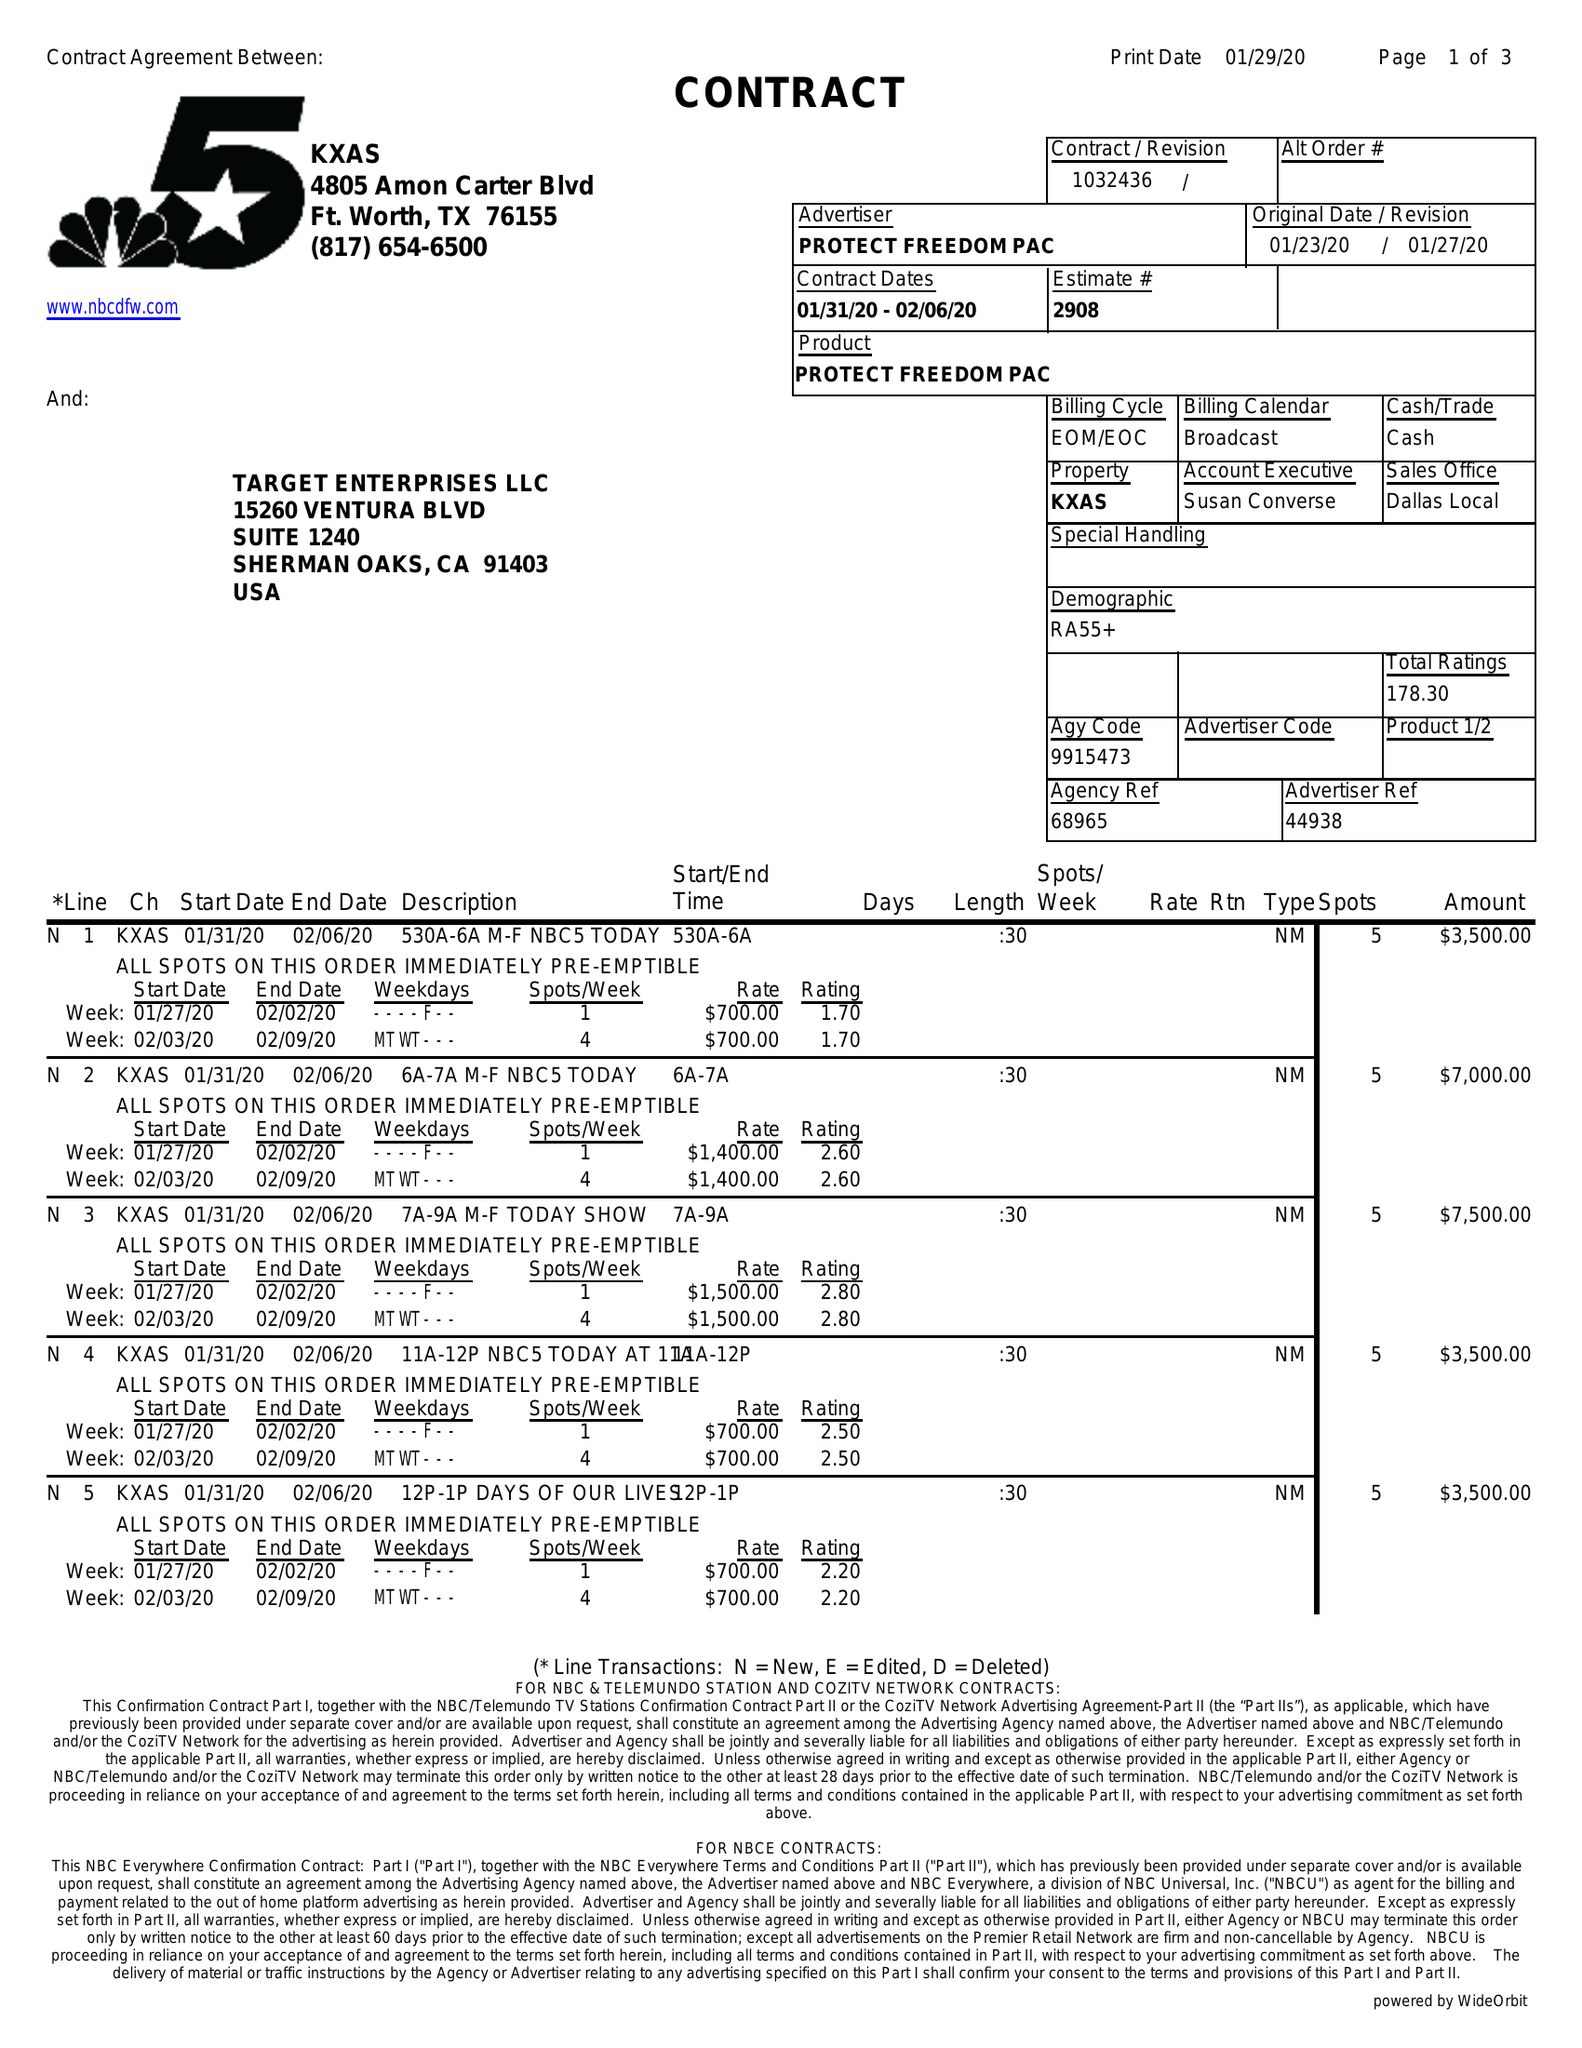What is the value for the gross_amount?
Answer the question using a single word or phrase. 72500.00 